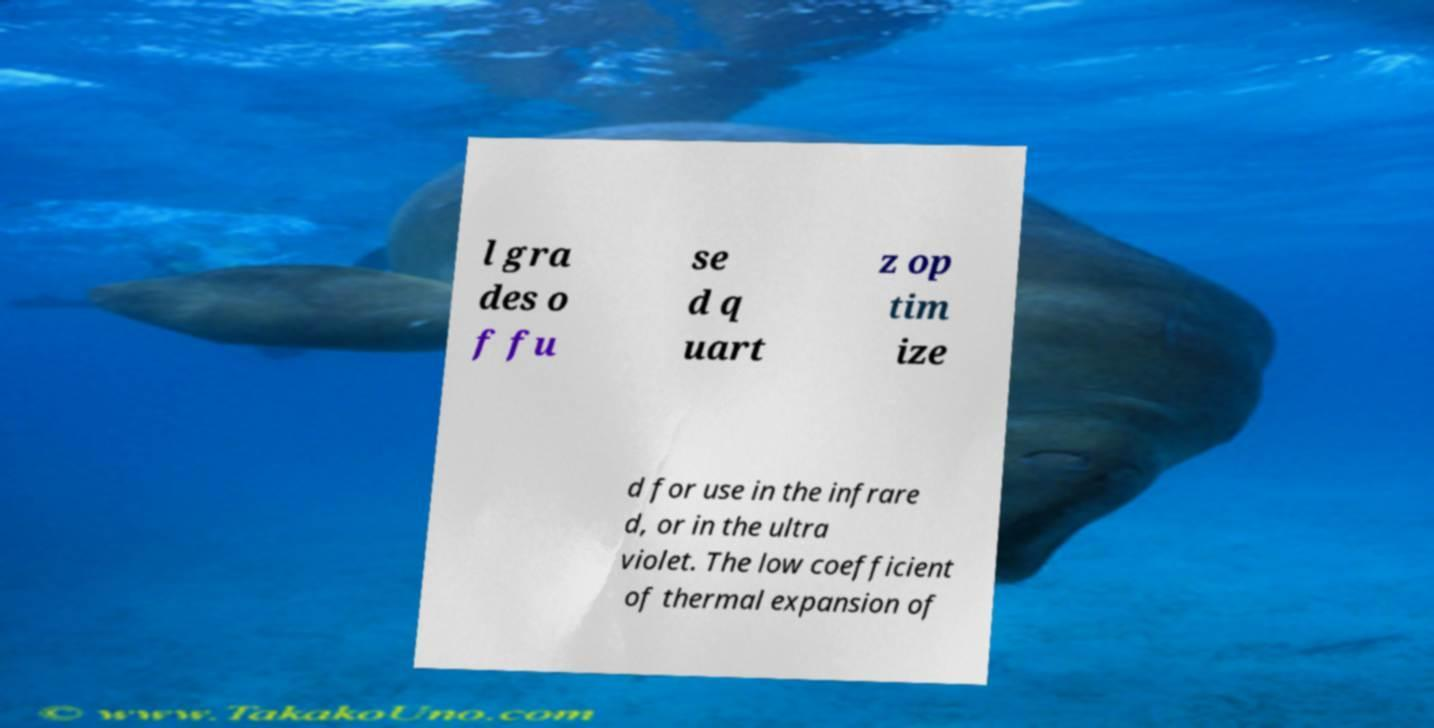Please identify and transcribe the text found in this image. l gra des o f fu se d q uart z op tim ize d for use in the infrare d, or in the ultra violet. The low coefficient of thermal expansion of 